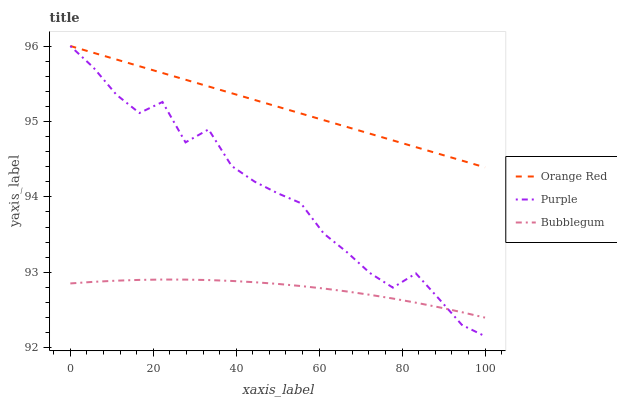Does Bubblegum have the minimum area under the curve?
Answer yes or no. Yes. Does Orange Red have the maximum area under the curve?
Answer yes or no. Yes. Does Orange Red have the minimum area under the curve?
Answer yes or no. No. Does Bubblegum have the maximum area under the curve?
Answer yes or no. No. Is Orange Red the smoothest?
Answer yes or no. Yes. Is Purple the roughest?
Answer yes or no. Yes. Is Bubblegum the smoothest?
Answer yes or no. No. Is Bubblegum the roughest?
Answer yes or no. No. Does Purple have the lowest value?
Answer yes or no. Yes. Does Bubblegum have the lowest value?
Answer yes or no. No. Does Orange Red have the highest value?
Answer yes or no. Yes. Does Bubblegum have the highest value?
Answer yes or no. No. Is Bubblegum less than Orange Red?
Answer yes or no. Yes. Is Orange Red greater than Bubblegum?
Answer yes or no. Yes. Does Purple intersect Bubblegum?
Answer yes or no. Yes. Is Purple less than Bubblegum?
Answer yes or no. No. Is Purple greater than Bubblegum?
Answer yes or no. No. Does Bubblegum intersect Orange Red?
Answer yes or no. No. 